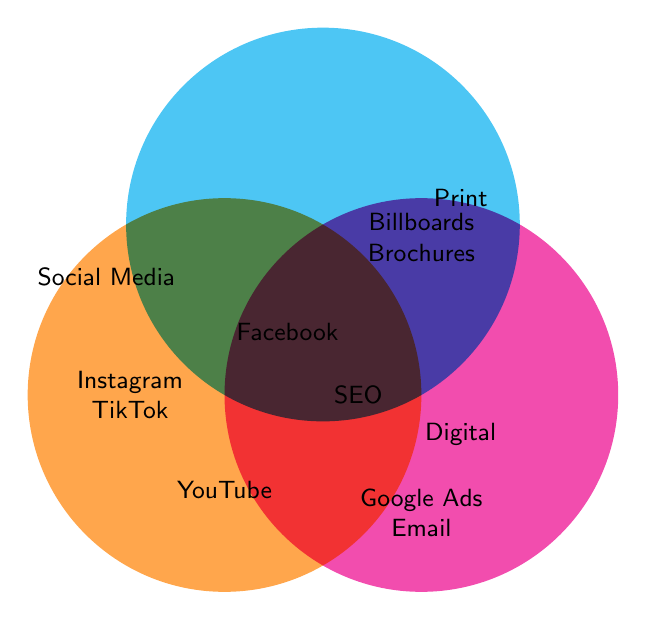What's one social media channel mentioned? Look inside the circle labeled "Social Media" for mentions of platform names.
Answer: Instagram Which marketing channels are unique to digital marketing? Look at the circle labeled "Digital" for elements only inside this circle.
Answer: Google Ads, Email Marketing What channels are specific to print marketing? Refer to the area inside the "Print" circle not overlapping with others.
Answer: Billboards, Brochures Which marketing channel falls under both social media and digital marketing? Look for elements in the overlapping area of "Social Media" and "Digital" circles.
Answer: Facebook Name a marketing channel that belongs to all three categories. Check the center area where all three circles intersect. There is no label in this area on the figure provided.
Answer: None What channels belong to both print and digital marketing, but not social media? Refer to the overlapping section of "Print" and "Digital" circles excluding the "Social Media" circle. The example provided does not have labels specifically in such an area.
Answer: None Which area lists only 'YouTube'? Identify a particular section in the "Social Media" circle not overlapping with others.
Answer: Social Media (lower part) Is there any overlap between print and social media marketing channels? Check for any elements at the intersection of "Social Media" and "Print" circles. No overlapping elements are labeled between these two in the given figure.
Answer: No How many unique print marketing channels are there? Count the marketing channels only in the "Print" circle outside any intersecting sections.
Answer: 2 